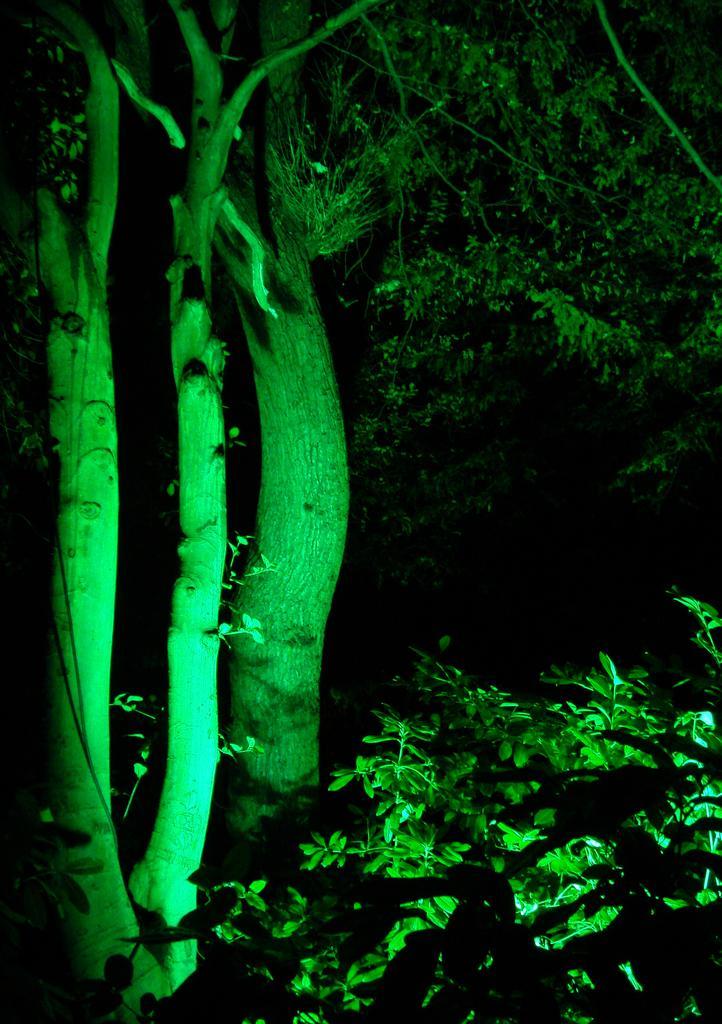Describe this image in one or two sentences. In this picture, it seems like trees and plants in the foreground. 